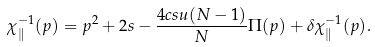<formula> <loc_0><loc_0><loc_500><loc_500>\chi _ { \| } ^ { - 1 } ( p ) = p ^ { 2 } + 2 s - \frac { 4 c s u ( N - 1 ) } { N } \Pi ( p ) + \delta \chi _ { \| } ^ { - 1 } ( p ) .</formula> 